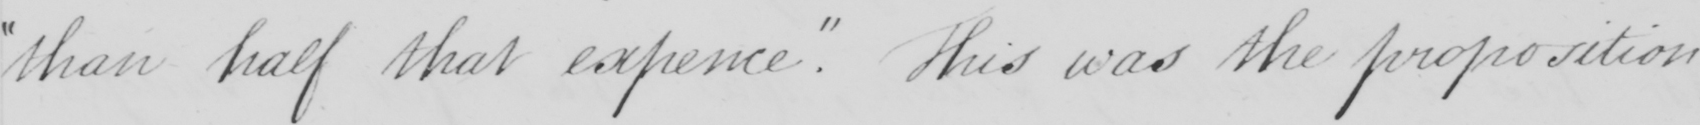Please provide the text content of this handwritten line. " than half that expence . "  This was the proposition 